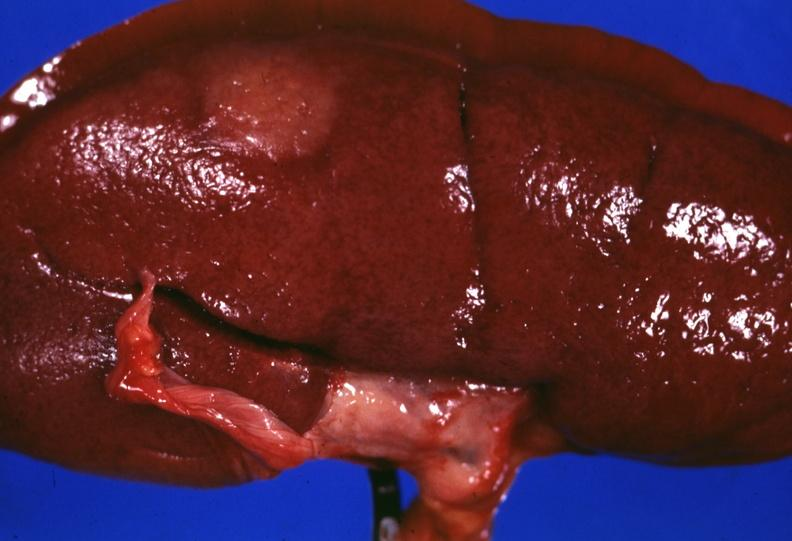s surface lesion capsule stripped unusual?
Answer the question using a single word or phrase. Yes 